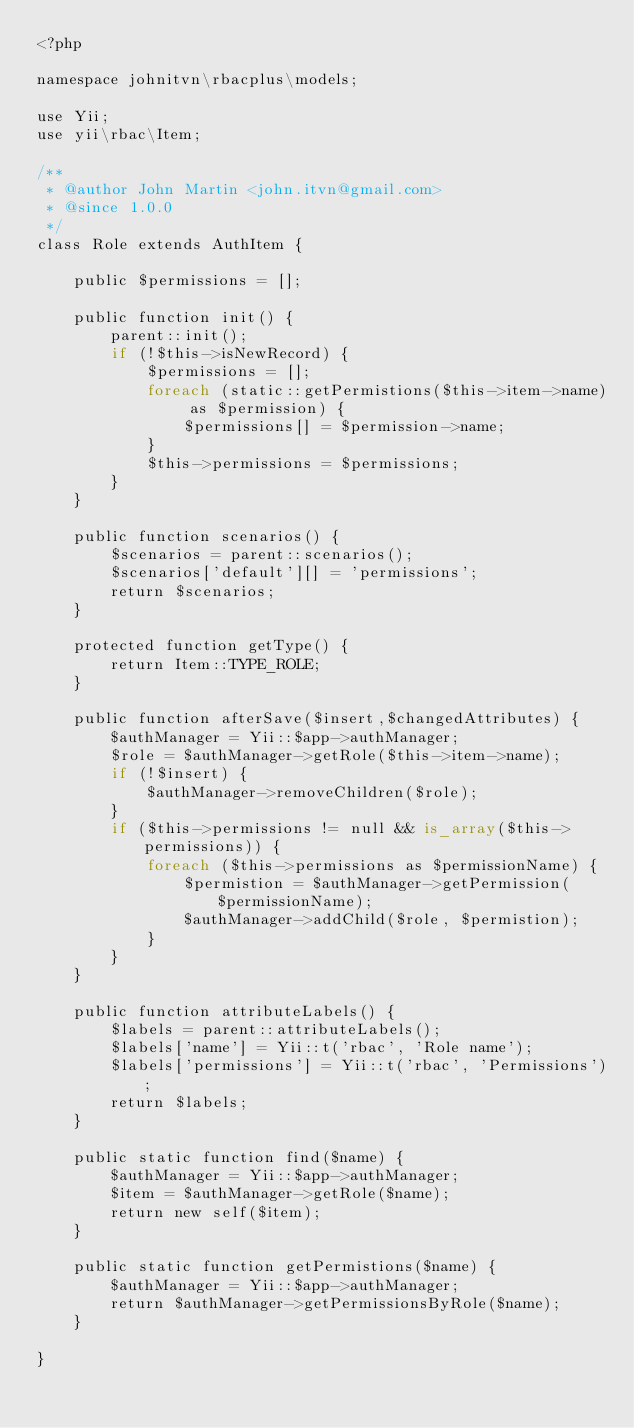Convert code to text. <code><loc_0><loc_0><loc_500><loc_500><_PHP_><?php

namespace johnitvn\rbacplus\models;

use Yii;
use yii\rbac\Item;

/**
 * @author John Martin <john.itvn@gmail.com>
 * @since 1.0.0
 */
class Role extends AuthItem {

    public $permissions = [];

    public function init() {
        parent::init();
        if (!$this->isNewRecord) {
            $permissions = [];
            foreach (static::getPermistions($this->item->name) as $permission) {
                $permissions[] = $permission->name;
            }
            $this->permissions = $permissions;
        }
    }

    public function scenarios() {
        $scenarios = parent::scenarios();
        $scenarios['default'][] = 'permissions';
        return $scenarios;
    }

    protected function getType() {
        return Item::TYPE_ROLE;
    }

    public function afterSave($insert,$changedAttributes) {
        $authManager = Yii::$app->authManager;
        $role = $authManager->getRole($this->item->name);
        if (!$insert) {
            $authManager->removeChildren($role);
        }
        if ($this->permissions != null && is_array($this->permissions)) {
            foreach ($this->permissions as $permissionName) {
                $permistion = $authManager->getPermission($permissionName);
                $authManager->addChild($role, $permistion);
            }
        }
    }

    public function attributeLabels() {
        $labels = parent::attributeLabels();
        $labels['name'] = Yii::t('rbac', 'Role name');
        $labels['permissions'] = Yii::t('rbac', 'Permissions');
        return $labels;
    }

    public static function find($name) {
        $authManager = Yii::$app->authManager;
        $item = $authManager->getRole($name);
        return new self($item);
    }

    public static function getPermistions($name) {
        $authManager = Yii::$app->authManager;
        return $authManager->getPermissionsByRole($name);
    }

}
</code> 